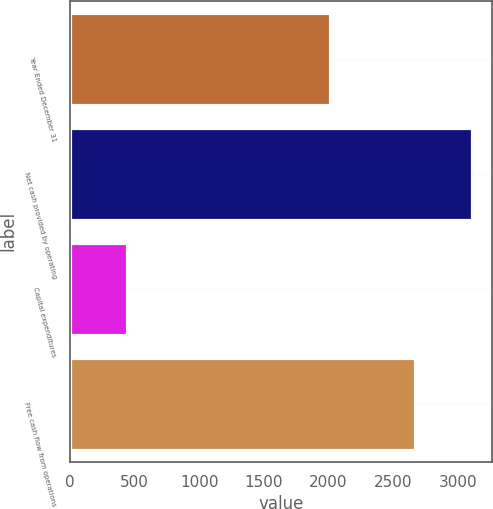<chart> <loc_0><loc_0><loc_500><loc_500><bar_chart><fcel>Year Ended December 31<fcel>Net cash provided by operating<fcel>Capital expenditures<fcel>Free cash flow from operations<nl><fcel>2013<fcel>3106<fcel>440<fcel>2666<nl></chart> 